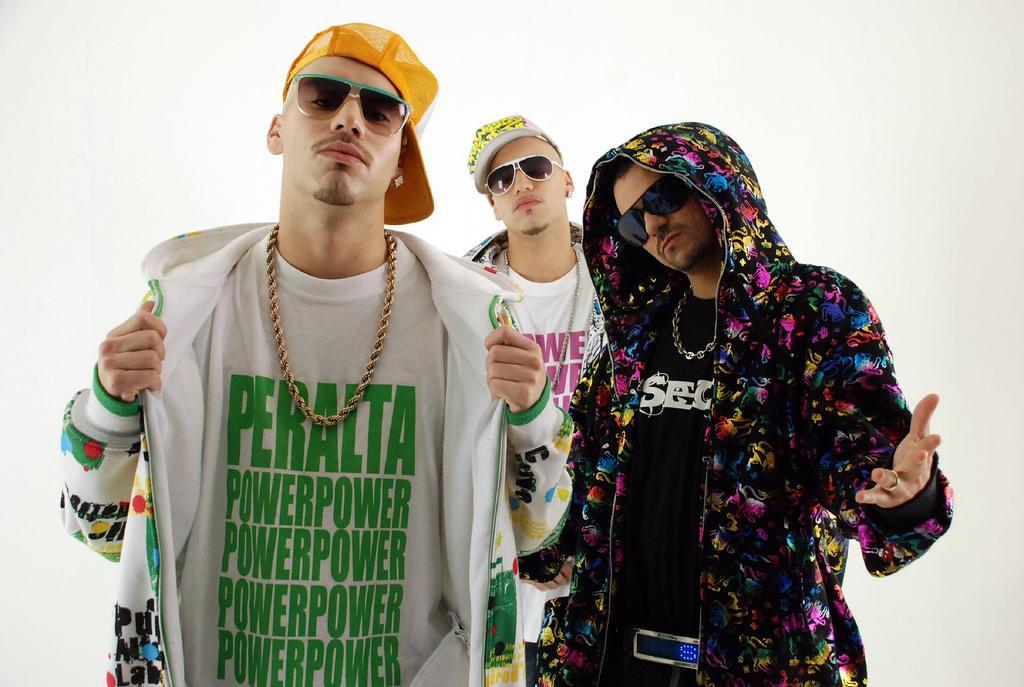Describe this image in one or two sentences. In this image there are three men standing, they are wearing goggles, they are wearing caps, the background of the image is white in color. 